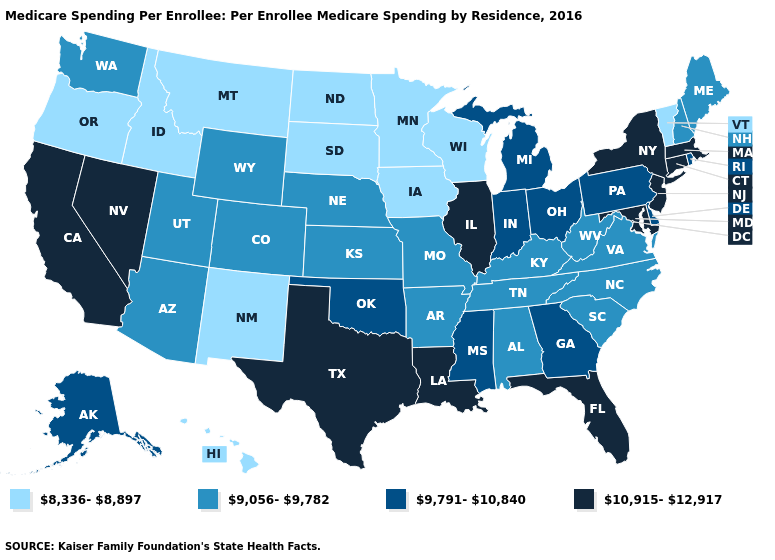Is the legend a continuous bar?
Write a very short answer. No. How many symbols are there in the legend?
Short answer required. 4. What is the highest value in states that border Montana?
Quick response, please. 9,056-9,782. What is the lowest value in the USA?
Be succinct. 8,336-8,897. Does the map have missing data?
Be succinct. No. Does Maine have a higher value than Arizona?
Keep it brief. No. What is the value of Washington?
Write a very short answer. 9,056-9,782. Name the states that have a value in the range 9,791-10,840?
Be succinct. Alaska, Delaware, Georgia, Indiana, Michigan, Mississippi, Ohio, Oklahoma, Pennsylvania, Rhode Island. Among the states that border New York , does Pennsylvania have the highest value?
Concise answer only. No. Is the legend a continuous bar?
Short answer required. No. Which states have the lowest value in the South?
Answer briefly. Alabama, Arkansas, Kentucky, North Carolina, South Carolina, Tennessee, Virginia, West Virginia. Among the states that border Iowa , which have the lowest value?
Be succinct. Minnesota, South Dakota, Wisconsin. Among the states that border South Carolina , does Georgia have the lowest value?
Give a very brief answer. No. What is the value of Montana?
Answer briefly. 8,336-8,897. Does Louisiana have the same value as Texas?
Give a very brief answer. Yes. 